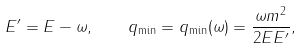<formula> <loc_0><loc_0><loc_500><loc_500>E ^ { \prime } = E - \omega , \quad q _ { \min } = q _ { \min } ( \omega ) = \frac { \omega m ^ { 2 } } { 2 E E ^ { \prime } } ,</formula> 